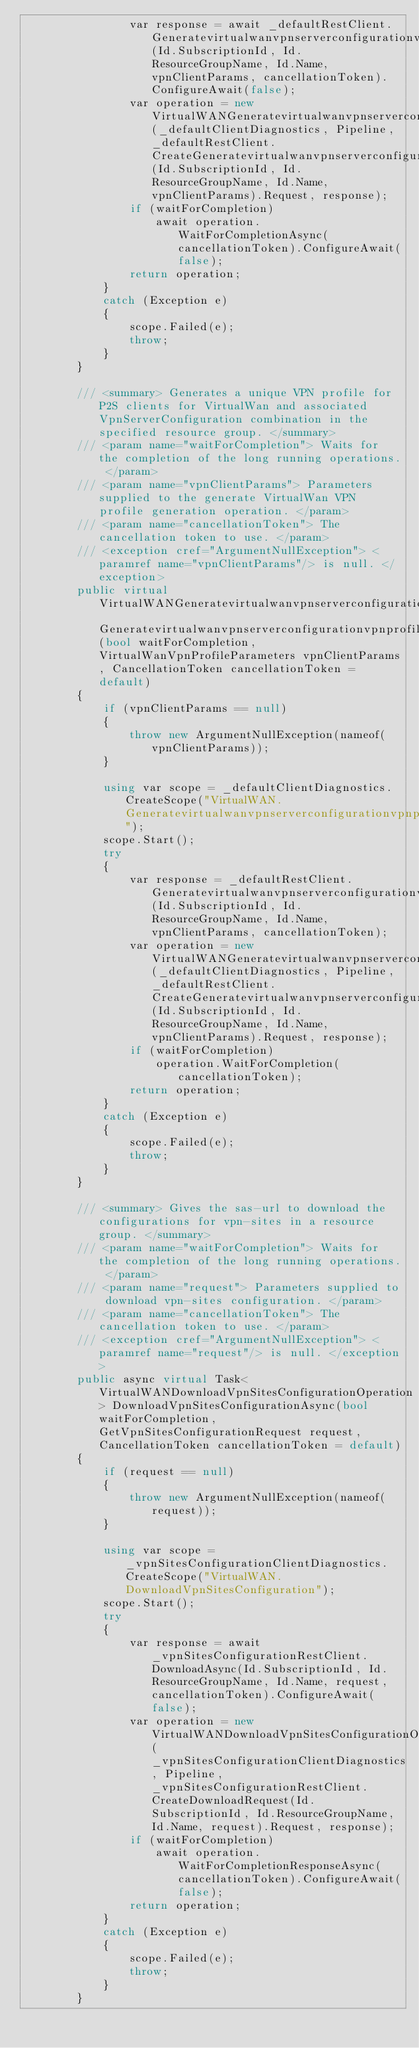<code> <loc_0><loc_0><loc_500><loc_500><_C#_>                var response = await _defaultRestClient.GeneratevirtualwanvpnserverconfigurationvpnprofileAsync(Id.SubscriptionId, Id.ResourceGroupName, Id.Name, vpnClientParams, cancellationToken).ConfigureAwait(false);
                var operation = new VirtualWANGeneratevirtualwanvpnserverconfigurationvpnprofileOperation(_defaultClientDiagnostics, Pipeline, _defaultRestClient.CreateGeneratevirtualwanvpnserverconfigurationvpnprofileRequest(Id.SubscriptionId, Id.ResourceGroupName, Id.Name, vpnClientParams).Request, response);
                if (waitForCompletion)
                    await operation.WaitForCompletionAsync(cancellationToken).ConfigureAwait(false);
                return operation;
            }
            catch (Exception e)
            {
                scope.Failed(e);
                throw;
            }
        }

        /// <summary> Generates a unique VPN profile for P2S clients for VirtualWan and associated VpnServerConfiguration combination in the specified resource group. </summary>
        /// <param name="waitForCompletion"> Waits for the completion of the long running operations. </param>
        /// <param name="vpnClientParams"> Parameters supplied to the generate VirtualWan VPN profile generation operation. </param>
        /// <param name="cancellationToken"> The cancellation token to use. </param>
        /// <exception cref="ArgumentNullException"> <paramref name="vpnClientParams"/> is null. </exception>
        public virtual VirtualWANGeneratevirtualwanvpnserverconfigurationvpnprofileOperation Generatevirtualwanvpnserverconfigurationvpnprofile(bool waitForCompletion, VirtualWanVpnProfileParameters vpnClientParams, CancellationToken cancellationToken = default)
        {
            if (vpnClientParams == null)
            {
                throw new ArgumentNullException(nameof(vpnClientParams));
            }

            using var scope = _defaultClientDiagnostics.CreateScope("VirtualWAN.Generatevirtualwanvpnserverconfigurationvpnprofile");
            scope.Start();
            try
            {
                var response = _defaultRestClient.Generatevirtualwanvpnserverconfigurationvpnprofile(Id.SubscriptionId, Id.ResourceGroupName, Id.Name, vpnClientParams, cancellationToken);
                var operation = new VirtualWANGeneratevirtualwanvpnserverconfigurationvpnprofileOperation(_defaultClientDiagnostics, Pipeline, _defaultRestClient.CreateGeneratevirtualwanvpnserverconfigurationvpnprofileRequest(Id.SubscriptionId, Id.ResourceGroupName, Id.Name, vpnClientParams).Request, response);
                if (waitForCompletion)
                    operation.WaitForCompletion(cancellationToken);
                return operation;
            }
            catch (Exception e)
            {
                scope.Failed(e);
                throw;
            }
        }

        /// <summary> Gives the sas-url to download the configurations for vpn-sites in a resource group. </summary>
        /// <param name="waitForCompletion"> Waits for the completion of the long running operations. </param>
        /// <param name="request"> Parameters supplied to download vpn-sites configuration. </param>
        /// <param name="cancellationToken"> The cancellation token to use. </param>
        /// <exception cref="ArgumentNullException"> <paramref name="request"/> is null. </exception>
        public async virtual Task<VirtualWANDownloadVpnSitesConfigurationOperation> DownloadVpnSitesConfigurationAsync(bool waitForCompletion, GetVpnSitesConfigurationRequest request, CancellationToken cancellationToken = default)
        {
            if (request == null)
            {
                throw new ArgumentNullException(nameof(request));
            }

            using var scope = _vpnSitesConfigurationClientDiagnostics.CreateScope("VirtualWAN.DownloadVpnSitesConfiguration");
            scope.Start();
            try
            {
                var response = await _vpnSitesConfigurationRestClient.DownloadAsync(Id.SubscriptionId, Id.ResourceGroupName, Id.Name, request, cancellationToken).ConfigureAwait(false);
                var operation = new VirtualWANDownloadVpnSitesConfigurationOperation(_vpnSitesConfigurationClientDiagnostics, Pipeline, _vpnSitesConfigurationRestClient.CreateDownloadRequest(Id.SubscriptionId, Id.ResourceGroupName, Id.Name, request).Request, response);
                if (waitForCompletion)
                    await operation.WaitForCompletionResponseAsync(cancellationToken).ConfigureAwait(false);
                return operation;
            }
            catch (Exception e)
            {
                scope.Failed(e);
                throw;
            }
        }
</code> 